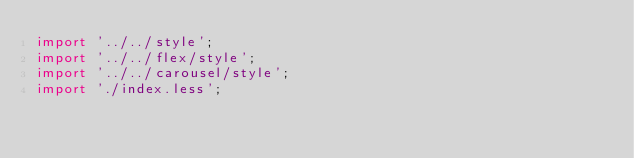Convert code to text. <code><loc_0><loc_0><loc_500><loc_500><_JavaScript_>import '../../style';
import '../../flex/style';
import '../../carousel/style';
import './index.less';</code> 